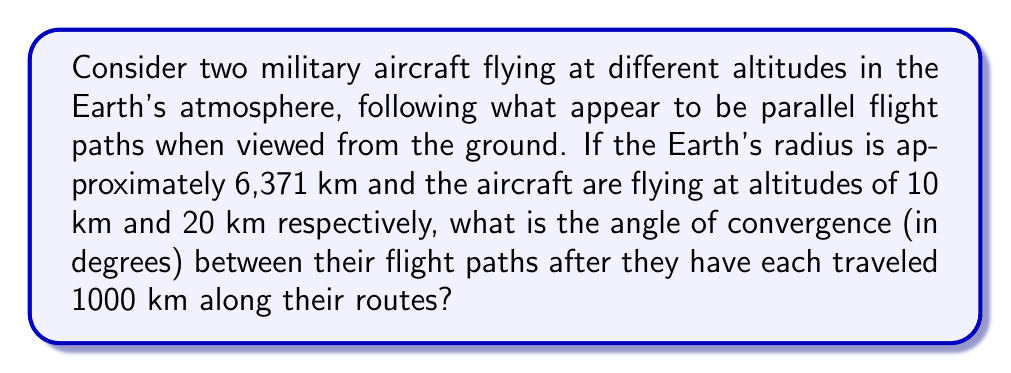Help me with this question. To solve this problem, we need to consider the curvature of the Earth and how it affects the flight paths of the aircraft. Let's approach this step-by-step:

1) First, we need to calculate the radii of the circular paths for each aircraft:
   $$r_1 = 6371 \text{ km} + 10 \text{ km} = 6381 \text{ km}$$
   $$r_2 = 6371 \text{ km} + 20 \text{ km} = 6391 \text{ km}$$

2) Now, we need to calculate the central angle subtended by the 1000 km arc for each aircraft:
   $$\theta_1 = \frac{1000 \text{ km}}{6381 \text{ km}} = 0.15672 \text{ radians}$$
   $$\theta_2 = \frac{1000 \text{ km}}{6391 \text{ km}} = 0.15646 \text{ radians}$$

3) The angle of convergence is the difference between these two angles:
   $$\Delta\theta = \theta_1 - \theta_2 = 0.15672 - 0.15646 = 0.00026 \text{ radians}$$

4) Convert this to degrees:
   $$\Delta\theta_{degrees} = 0.00026 \times \frac{180}{\pi} = 0.0149°$$

5) Round to four decimal places:
   $$\Delta\theta_{degrees} \approx 0.0149°$$

This small angle of convergence demonstrates how paths that appear parallel on a curved surface (like the Earth) actually converge over large distances.

[asy]
import geometry;

size(200);
real R = 100;
real h1 = 1.57;
real h2 = 3.14;
real theta = 15.672;

path earth = Circle((0,0), R);
path path1 = Arc((0,0), R+h1, -90, -90+theta);
path path2 = Arc((0,0), R+h2, -90, -90+theta);

draw(earth);
draw(path1, blue);
draw(path2, red);

label("Earth", (0,-R), S);
label("Lower aircraft path", (R+h1,0), E);
label("Higher aircraft path", (R+h2,0), E);

draw((0,0)--(R+h2,0), dashed);
draw((-R-h2,0)--(R+h2,0), dashed);
[/asy]
Answer: 0.0149° 